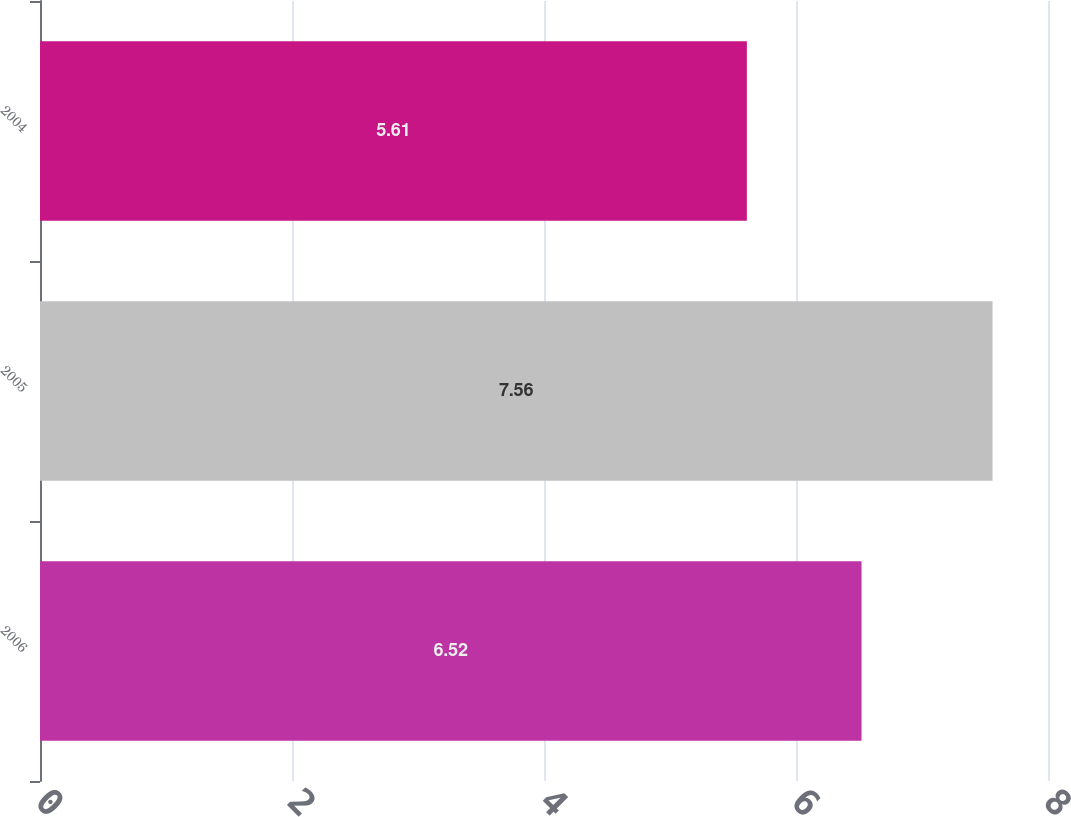<chart> <loc_0><loc_0><loc_500><loc_500><bar_chart><fcel>2006<fcel>2005<fcel>2004<nl><fcel>6.52<fcel>7.56<fcel>5.61<nl></chart> 